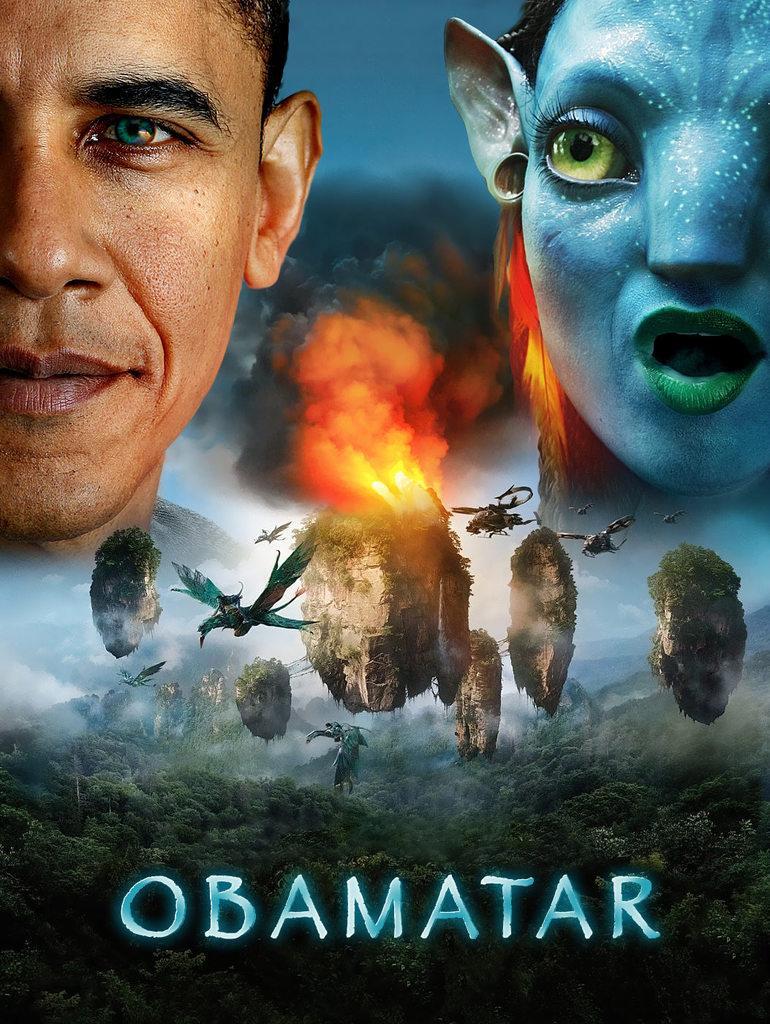Please provide a concise description of this image. In this image, we can see a person face in the top left of the image. There are rocks, birds and helicopters in the middle of the image. There is a text at the bottom of the image. There is an alien face in the top right of the image. 